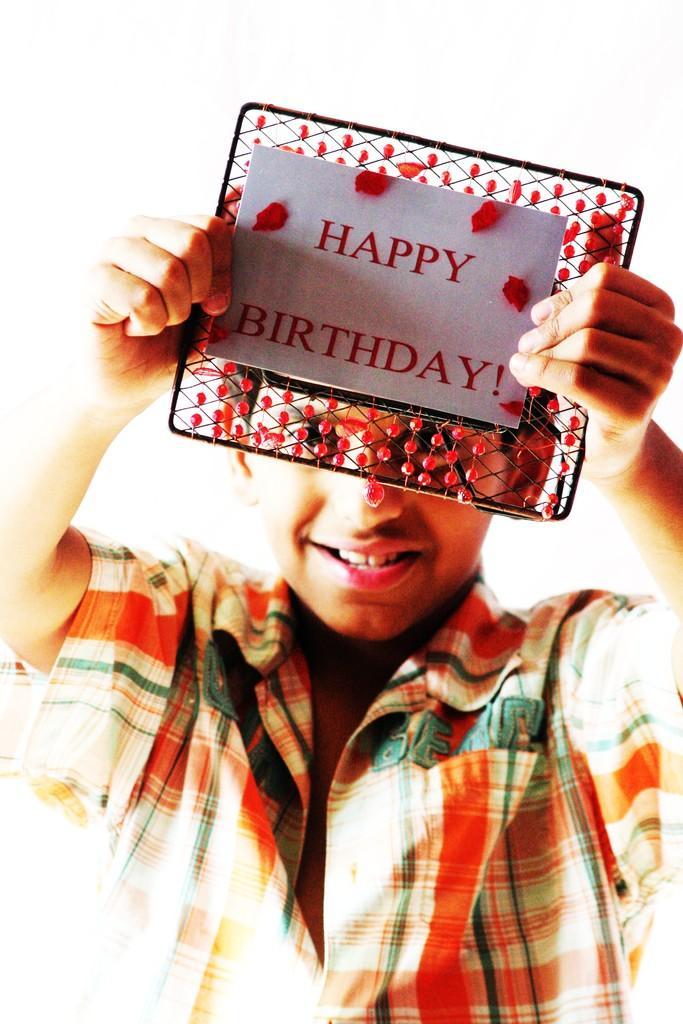Please provide a concise description of this image. This image consists of a person. He is holding a card. On that ''Happy Birthday'' is written. 